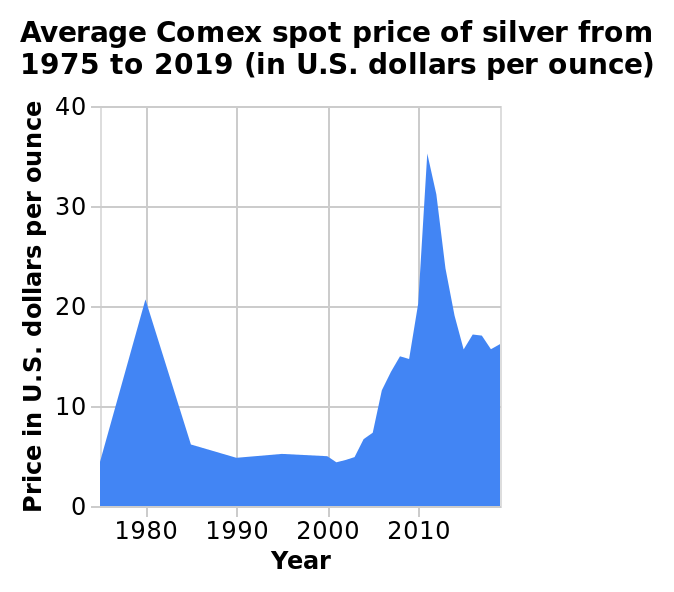<image>
What is the increment of the x-axis?  The increment of the x-axis is 10 years. What is the title of the area chart?  The title of the area chart is "Average Comex spot price of silver from 1975 to 2019 (in U.S. dollars per ounce)". What was the lowest price recorded?  The lowest price recorded was in 2001. What does the y-axis measure?  The y-axis measures the price of silver in U.S. dollars per ounce. 